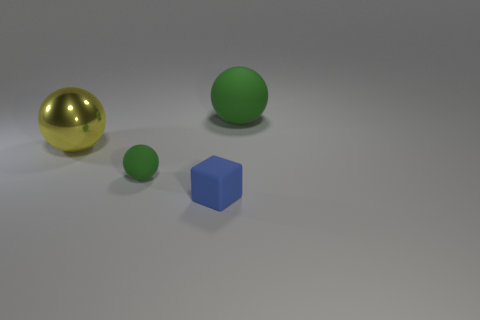Can you describe the lighting and shadow effects in the scene? Certainly, the image shows a healthy amount of ambient light with what seems like a primary light source emitting from the upper right side, as evidenced by the way shadows are cast. Each object casts a distinct shadow on the grey surface, with the shadows being crisp and firmly defined, suggesting that the light source is not overly diffused. The metallic sphere reflects light and has a bright highlight, which adds to its realistic metallic texture. 